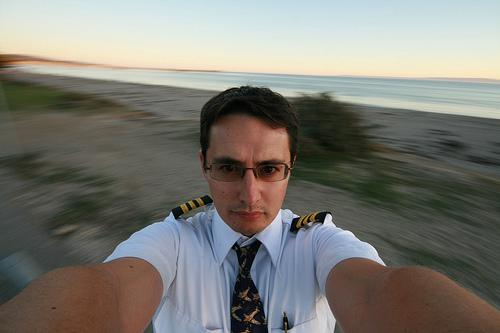Question: how does the man look?
Choices:
A. The man looks sad.
B. The man looks serious.
C. The man looks happy.
D. The man looks hopeful.
Answer with the letter. Answer: B Question: what color is the man's shirt?
Choices:
A. Red.
B. Blue.
C. Orange.
D. The man's shirt is white.
Answer with the letter. Answer: D Question: when did this picture get taken?
Choices:
A. It was taken in the day time.
B. It was taken at dawn.
C. It was taken at midnight.
D. It was taken at dusk.
Answer with the letter. Answer: A Question: why did he take this picture?
Choices:
A. To remember what the people looked like.
B. To show people how he looks.
C. To remember the moment.
D. Someone asked him to.
Answer with the letter. Answer: B Question: who is in the picture with the man?
Choices:
A. Nobody is with the man.
B. Daughter.
C. Mom.
D. Wife.
Answer with the letter. Answer: A Question: where did this picture take place?
Choices:
A. Mountain.
B. Ski slopes.
C. Waterfalls.
D. It took place on the beach.
Answer with the letter. Answer: D 